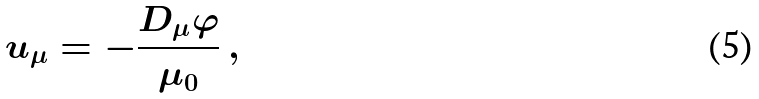Convert formula to latex. <formula><loc_0><loc_0><loc_500><loc_500>u _ { \mu } = - \frac { D _ { \mu } \varphi } { \mu _ { 0 } } \, ,</formula> 